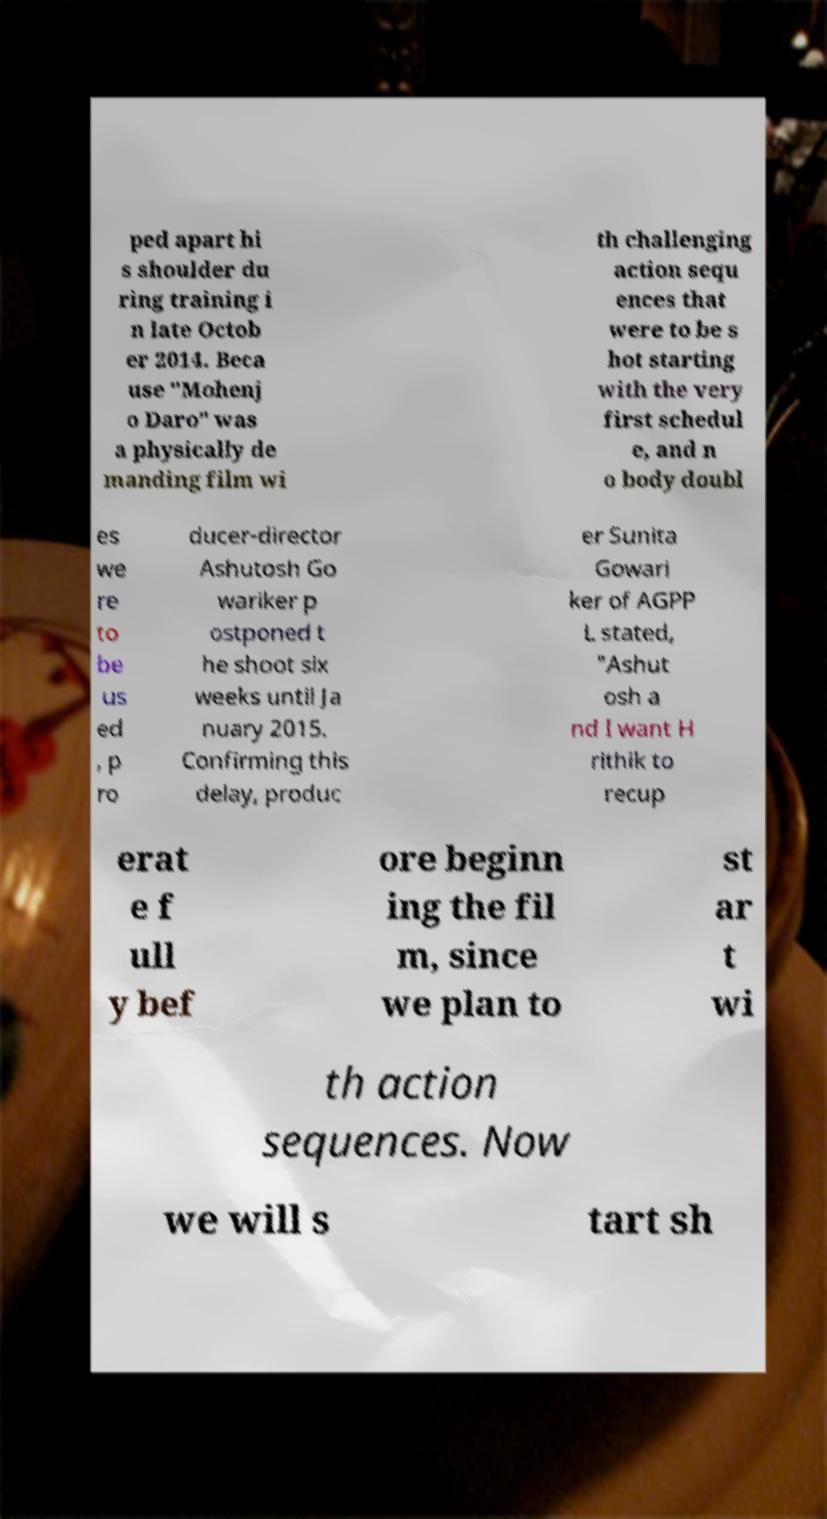I need the written content from this picture converted into text. Can you do that? ped apart hi s shoulder du ring training i n late Octob er 2014. Beca use "Mohenj o Daro" was a physically de manding film wi th challenging action sequ ences that were to be s hot starting with the very first schedul e, and n o body doubl es we re to be us ed , p ro ducer-director Ashutosh Go wariker p ostponed t he shoot six weeks until Ja nuary 2015. Confirming this delay, produc er Sunita Gowari ker of AGPP L stated, "Ashut osh a nd I want H rithik to recup erat e f ull y bef ore beginn ing the fil m, since we plan to st ar t wi th action sequences. Now we will s tart sh 